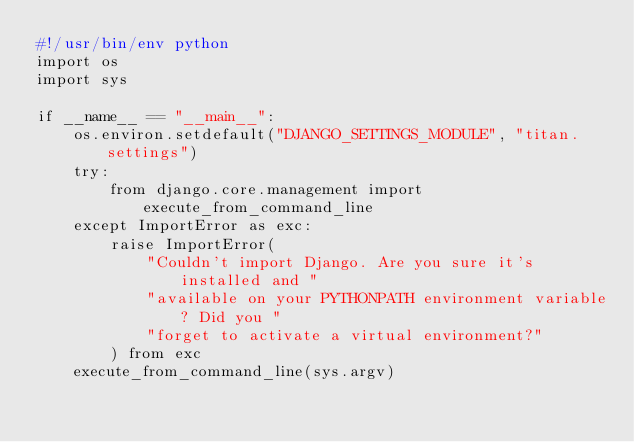<code> <loc_0><loc_0><loc_500><loc_500><_Python_>#!/usr/bin/env python
import os
import sys

if __name__ == "__main__":
    os.environ.setdefault("DJANGO_SETTINGS_MODULE", "titan.settings")
    try:
        from django.core.management import execute_from_command_line
    except ImportError as exc:
        raise ImportError(
            "Couldn't import Django. Are you sure it's installed and "
            "available on your PYTHONPATH environment variable? Did you "
            "forget to activate a virtual environment?"
        ) from exc
    execute_from_command_line(sys.argv)
</code> 